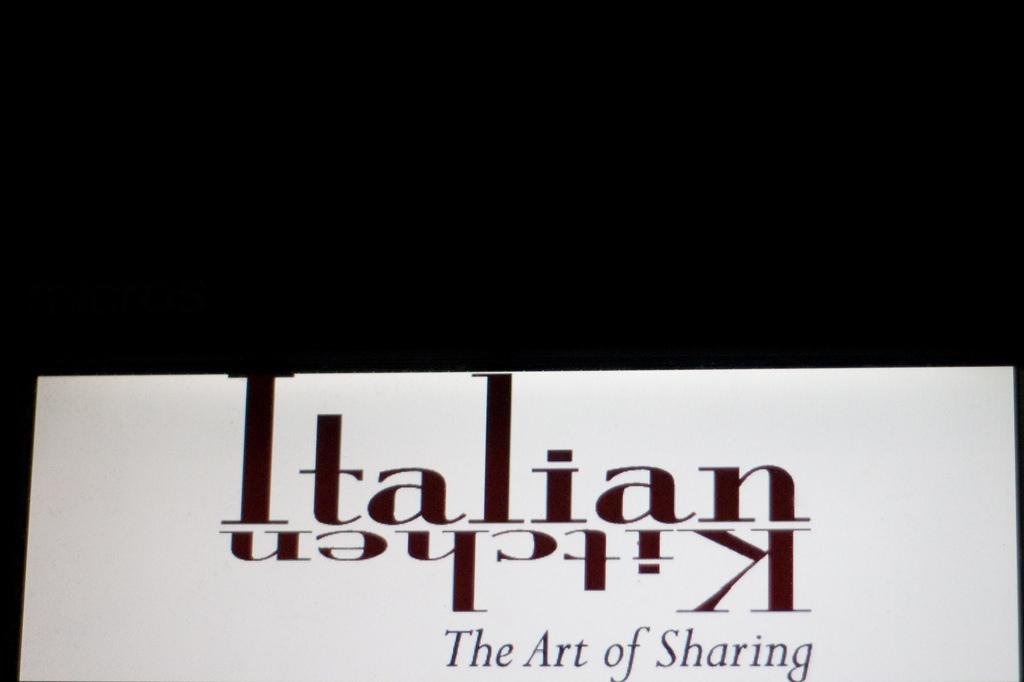<image>
Offer a succinct explanation of the picture presented. The paper shows the an Italian kitchen and sharing with people. 